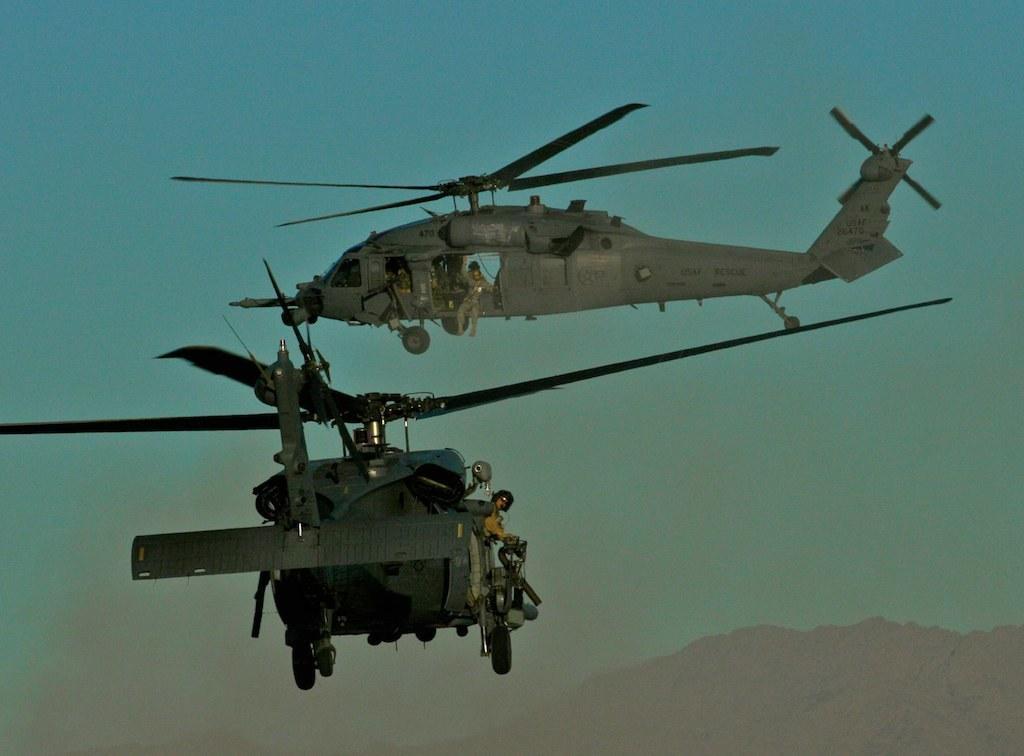How would you summarize this image in a sentence or two? In this image I can see two aircrafts in the air and mountains. In the background I can see the blue sky. This image is taken may be during a day. 